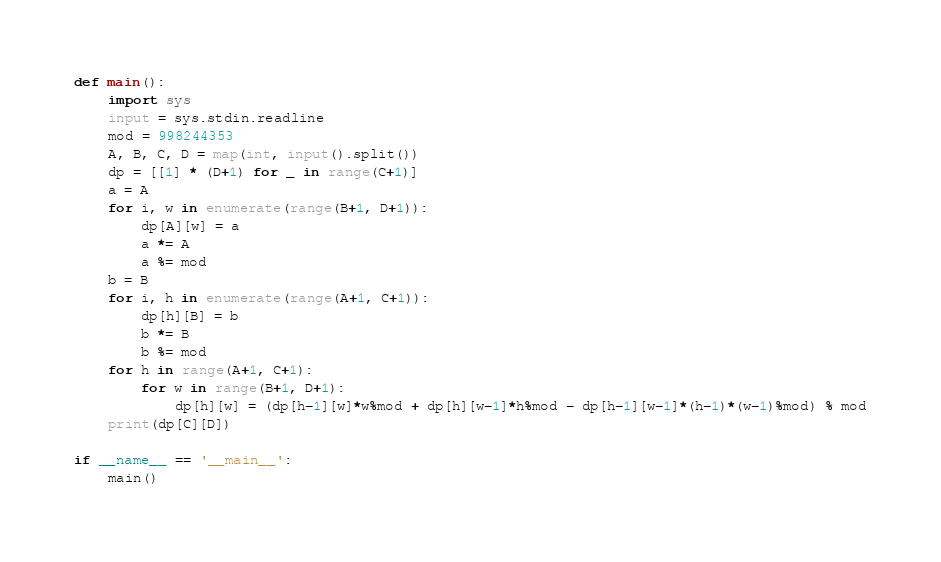Convert code to text. <code><loc_0><loc_0><loc_500><loc_500><_Python_>def main():
    import sys
    input = sys.stdin.readline
    mod = 998244353
    A, B, C, D = map(int, input().split())
    dp = [[1] * (D+1) for _ in range(C+1)]
    a = A
    for i, w in enumerate(range(B+1, D+1)):
        dp[A][w] = a
        a *= A
        a %= mod
    b = B
    for i, h in enumerate(range(A+1, C+1)):
        dp[h][B] = b
        b *= B
        b %= mod
    for h in range(A+1, C+1):
        for w in range(B+1, D+1):
            dp[h][w] = (dp[h-1][w]*w%mod + dp[h][w-1]*h%mod - dp[h-1][w-1]*(h-1)*(w-1)%mod) % mod
    print(dp[C][D])

if __name__ == '__main__':
    main()</code> 